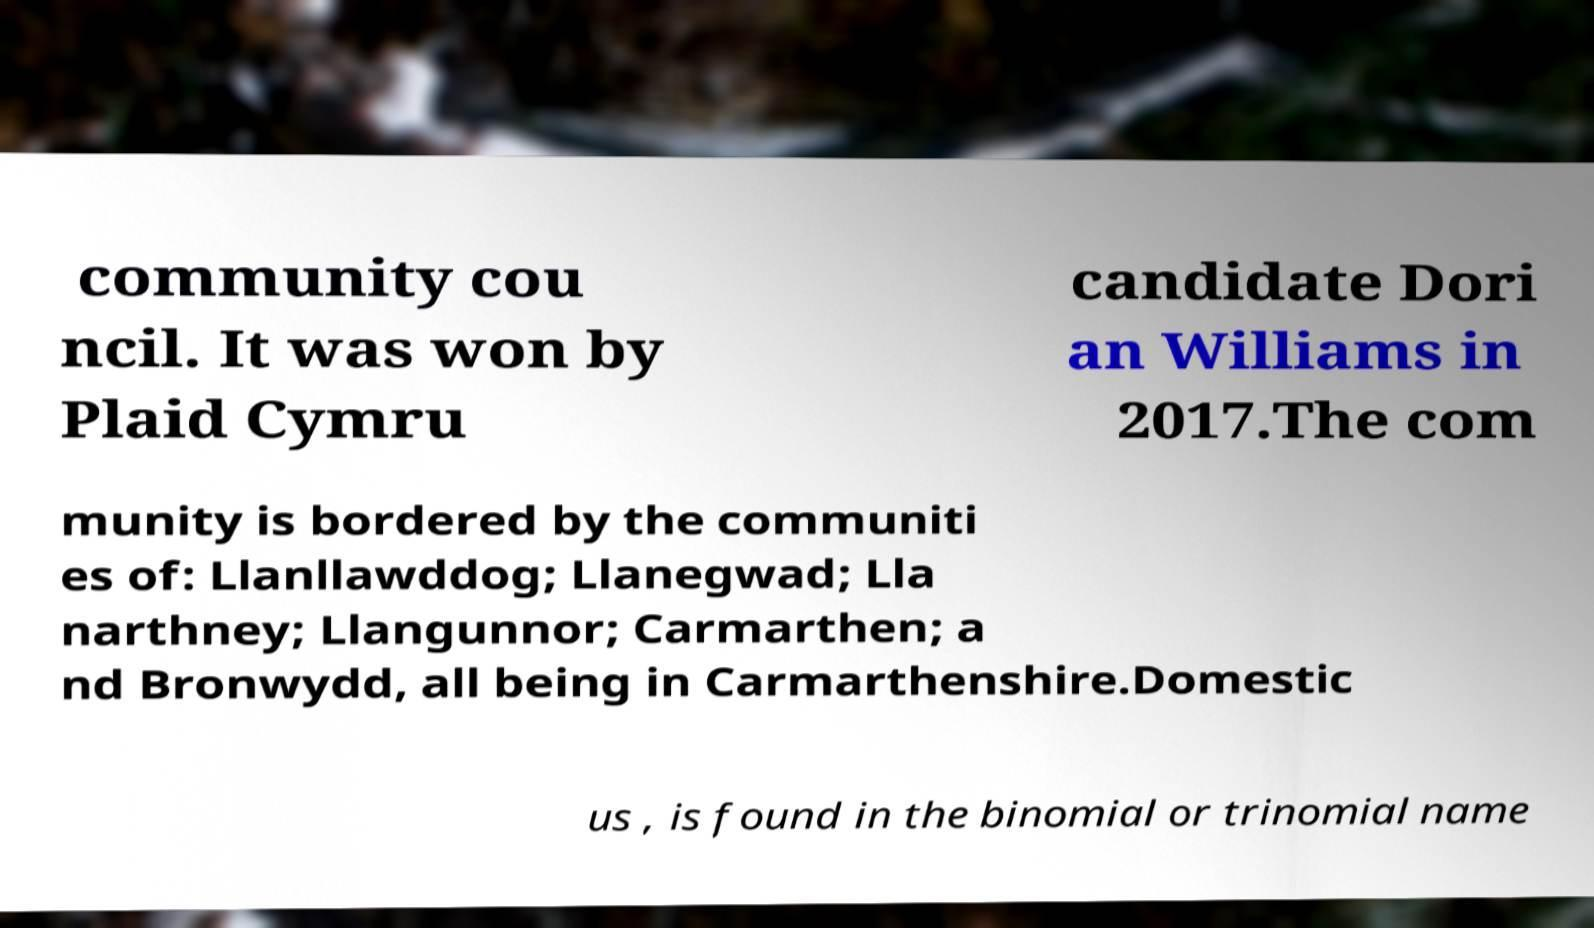There's text embedded in this image that I need extracted. Can you transcribe it verbatim? community cou ncil. It was won by Plaid Cymru candidate Dori an Williams in 2017.The com munity is bordered by the communiti es of: Llanllawddog; Llanegwad; Lla narthney; Llangunnor; Carmarthen; a nd Bronwydd, all being in Carmarthenshire.Domestic us , is found in the binomial or trinomial name 